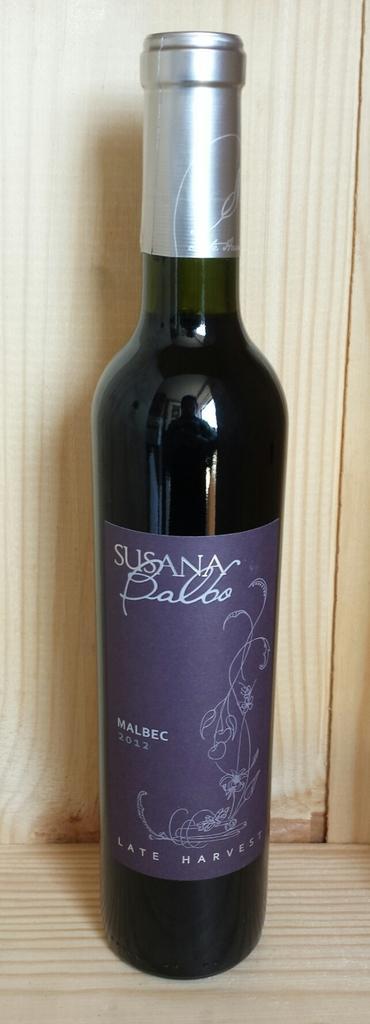In one or two sentences, can you explain what this image depicts? We can able to see a bottle. On this bottle there is a reflection of the person standing and a sticker. 